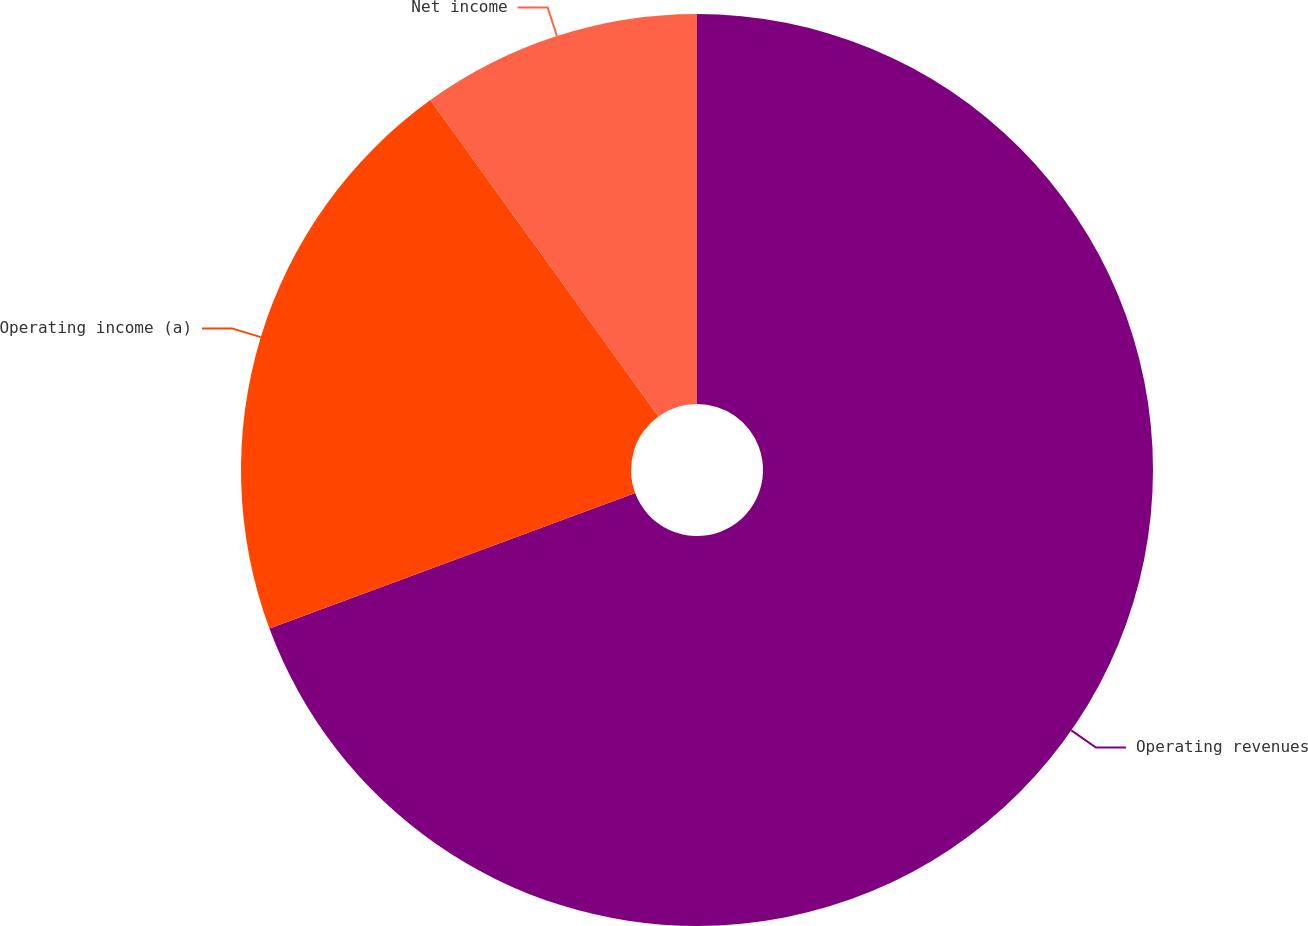<chart> <loc_0><loc_0><loc_500><loc_500><pie_chart><fcel>Operating revenues<fcel>Operating income (a)<fcel>Net income<nl><fcel>69.35%<fcel>20.71%<fcel>9.94%<nl></chart> 